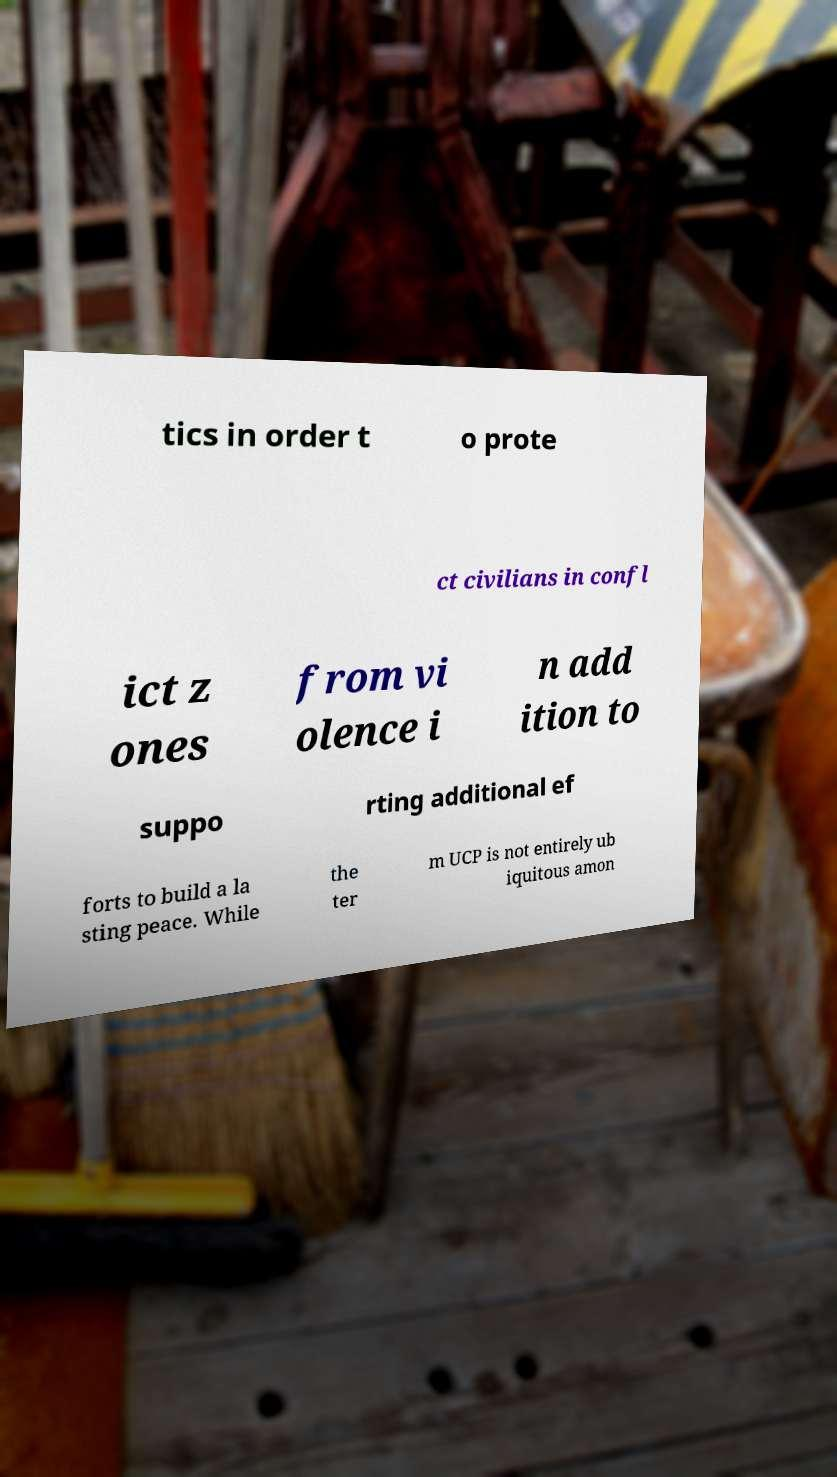There's text embedded in this image that I need extracted. Can you transcribe it verbatim? tics in order t o prote ct civilians in confl ict z ones from vi olence i n add ition to suppo rting additional ef forts to build a la sting peace. While the ter m UCP is not entirely ub iquitous amon 